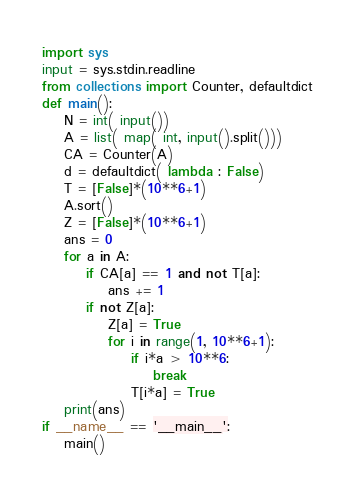Convert code to text. <code><loc_0><loc_0><loc_500><loc_500><_Python_>import sys
input = sys.stdin.readline
from collections import Counter, defaultdict
def main():
    N = int( input())
    A = list( map( int, input().split()))
    CA = Counter(A)
    d = defaultdict( lambda : False)
    T = [False]*(10**6+1)
    A.sort()
    Z = [False]*(10**6+1)
    ans = 0
    for a in A:
        if CA[a] == 1 and not T[a]:
            ans += 1
        if not Z[a]:
            Z[a] = True
            for i in range(1, 10**6+1):
                if i*a > 10**6:
                    break
                T[i*a] = True
    print(ans)
if __name__ == '__main__':
    main()
</code> 